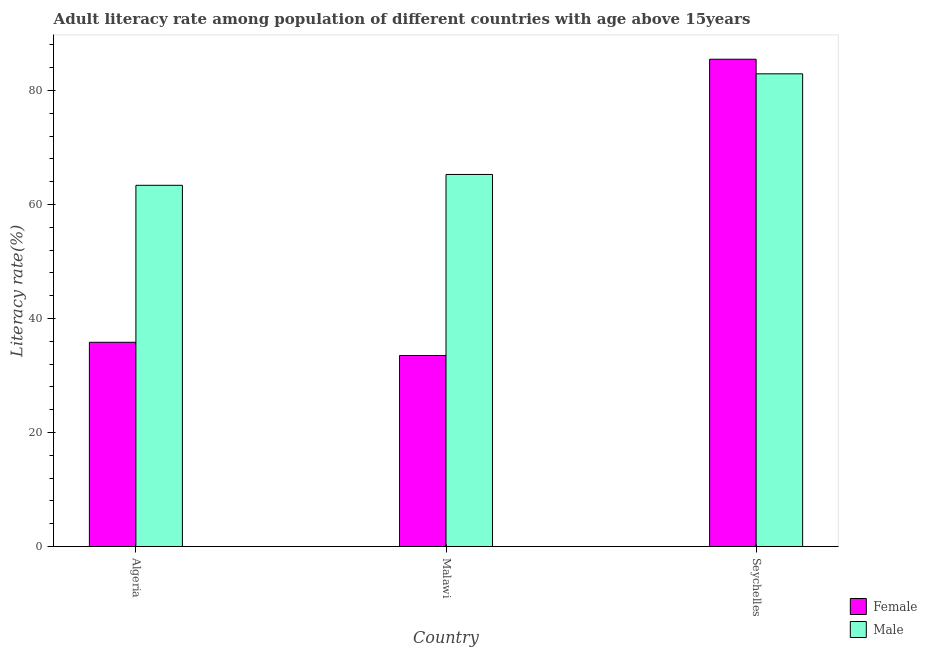How many bars are there on the 2nd tick from the right?
Give a very brief answer. 2. What is the label of the 2nd group of bars from the left?
Offer a very short reply. Malawi. In how many cases, is the number of bars for a given country not equal to the number of legend labels?
Keep it short and to the point. 0. What is the female adult literacy rate in Seychelles?
Provide a short and direct response. 85.49. Across all countries, what is the maximum female adult literacy rate?
Your answer should be very brief. 85.49. Across all countries, what is the minimum female adult literacy rate?
Your answer should be very brief. 33.52. In which country was the female adult literacy rate maximum?
Your answer should be very brief. Seychelles. In which country was the male adult literacy rate minimum?
Make the answer very short. Algeria. What is the total male adult literacy rate in the graph?
Your answer should be very brief. 211.59. What is the difference between the female adult literacy rate in Algeria and that in Seychelles?
Your answer should be compact. -49.65. What is the difference between the female adult literacy rate in Algeria and the male adult literacy rate in Malawi?
Keep it short and to the point. -29.44. What is the average male adult literacy rate per country?
Provide a succinct answer. 70.53. What is the difference between the male adult literacy rate and female adult literacy rate in Seychelles?
Offer a very short reply. -2.56. What is the ratio of the male adult literacy rate in Algeria to that in Malawi?
Offer a very short reply. 0.97. What is the difference between the highest and the second highest male adult literacy rate?
Ensure brevity in your answer.  17.65. What is the difference between the highest and the lowest female adult literacy rate?
Make the answer very short. 51.97. What does the 2nd bar from the right in Algeria represents?
Your answer should be compact. Female. How many bars are there?
Ensure brevity in your answer.  6. Where does the legend appear in the graph?
Provide a short and direct response. Bottom right. How many legend labels are there?
Your answer should be compact. 2. What is the title of the graph?
Your answer should be very brief. Adult literacy rate among population of different countries with age above 15years. Does "Grants" appear as one of the legend labels in the graph?
Offer a terse response. No. What is the label or title of the X-axis?
Provide a short and direct response. Country. What is the label or title of the Y-axis?
Offer a very short reply. Literacy rate(%). What is the Literacy rate(%) of Female in Algeria?
Provide a succinct answer. 35.84. What is the Literacy rate(%) in Male in Algeria?
Your answer should be compact. 63.38. What is the Literacy rate(%) in Female in Malawi?
Offer a very short reply. 33.52. What is the Literacy rate(%) of Male in Malawi?
Give a very brief answer. 65.28. What is the Literacy rate(%) of Female in Seychelles?
Offer a terse response. 85.49. What is the Literacy rate(%) in Male in Seychelles?
Provide a succinct answer. 82.93. Across all countries, what is the maximum Literacy rate(%) of Female?
Provide a succinct answer. 85.49. Across all countries, what is the maximum Literacy rate(%) in Male?
Your answer should be compact. 82.93. Across all countries, what is the minimum Literacy rate(%) of Female?
Ensure brevity in your answer.  33.52. Across all countries, what is the minimum Literacy rate(%) of Male?
Your answer should be very brief. 63.38. What is the total Literacy rate(%) of Female in the graph?
Ensure brevity in your answer.  154.85. What is the total Literacy rate(%) of Male in the graph?
Give a very brief answer. 211.59. What is the difference between the Literacy rate(%) of Female in Algeria and that in Malawi?
Offer a terse response. 2.32. What is the difference between the Literacy rate(%) of Male in Algeria and that in Malawi?
Make the answer very short. -1.9. What is the difference between the Literacy rate(%) in Female in Algeria and that in Seychelles?
Your answer should be compact. -49.65. What is the difference between the Literacy rate(%) in Male in Algeria and that in Seychelles?
Your response must be concise. -19.55. What is the difference between the Literacy rate(%) of Female in Malawi and that in Seychelles?
Your answer should be very brief. -51.97. What is the difference between the Literacy rate(%) in Male in Malawi and that in Seychelles?
Your answer should be very brief. -17.65. What is the difference between the Literacy rate(%) in Female in Algeria and the Literacy rate(%) in Male in Malawi?
Provide a short and direct response. -29.44. What is the difference between the Literacy rate(%) in Female in Algeria and the Literacy rate(%) in Male in Seychelles?
Make the answer very short. -47.09. What is the difference between the Literacy rate(%) of Female in Malawi and the Literacy rate(%) of Male in Seychelles?
Provide a short and direct response. -49.41. What is the average Literacy rate(%) in Female per country?
Provide a short and direct response. 51.62. What is the average Literacy rate(%) of Male per country?
Offer a very short reply. 70.53. What is the difference between the Literacy rate(%) of Female and Literacy rate(%) of Male in Algeria?
Make the answer very short. -27.54. What is the difference between the Literacy rate(%) in Female and Literacy rate(%) in Male in Malawi?
Your answer should be compact. -31.76. What is the difference between the Literacy rate(%) of Female and Literacy rate(%) of Male in Seychelles?
Your answer should be compact. 2.56. What is the ratio of the Literacy rate(%) in Female in Algeria to that in Malawi?
Your answer should be compact. 1.07. What is the ratio of the Literacy rate(%) in Male in Algeria to that in Malawi?
Offer a very short reply. 0.97. What is the ratio of the Literacy rate(%) of Female in Algeria to that in Seychelles?
Provide a short and direct response. 0.42. What is the ratio of the Literacy rate(%) of Male in Algeria to that in Seychelles?
Give a very brief answer. 0.76. What is the ratio of the Literacy rate(%) in Female in Malawi to that in Seychelles?
Your answer should be compact. 0.39. What is the ratio of the Literacy rate(%) in Male in Malawi to that in Seychelles?
Keep it short and to the point. 0.79. What is the difference between the highest and the second highest Literacy rate(%) of Female?
Give a very brief answer. 49.65. What is the difference between the highest and the second highest Literacy rate(%) of Male?
Provide a short and direct response. 17.65. What is the difference between the highest and the lowest Literacy rate(%) in Female?
Make the answer very short. 51.97. What is the difference between the highest and the lowest Literacy rate(%) in Male?
Offer a terse response. 19.55. 